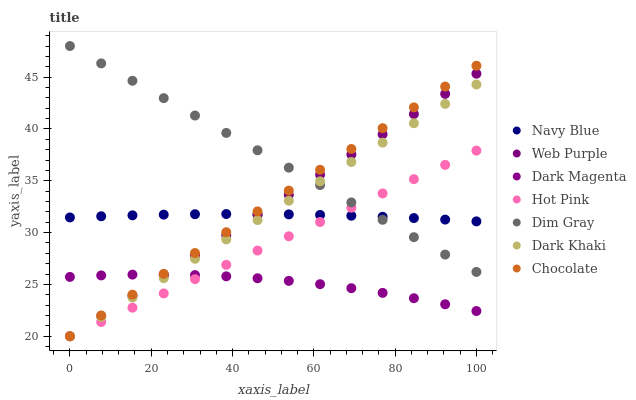Does Dark Magenta have the minimum area under the curve?
Answer yes or no. Yes. Does Dim Gray have the maximum area under the curve?
Answer yes or no. Yes. Does Navy Blue have the minimum area under the curve?
Answer yes or no. No. Does Navy Blue have the maximum area under the curve?
Answer yes or no. No. Is Hot Pink the smoothest?
Answer yes or no. Yes. Is Dark Magenta the roughest?
Answer yes or no. Yes. Is Navy Blue the smoothest?
Answer yes or no. No. Is Navy Blue the roughest?
Answer yes or no. No. Does Hot Pink have the lowest value?
Answer yes or no. Yes. Does Dark Magenta have the lowest value?
Answer yes or no. No. Does Dim Gray have the highest value?
Answer yes or no. Yes. Does Navy Blue have the highest value?
Answer yes or no. No. Is Dark Magenta less than Dim Gray?
Answer yes or no. Yes. Is Dim Gray greater than Dark Magenta?
Answer yes or no. Yes. Does Dark Khaki intersect Web Purple?
Answer yes or no. Yes. Is Dark Khaki less than Web Purple?
Answer yes or no. No. Is Dark Khaki greater than Web Purple?
Answer yes or no. No. Does Dark Magenta intersect Dim Gray?
Answer yes or no. No. 